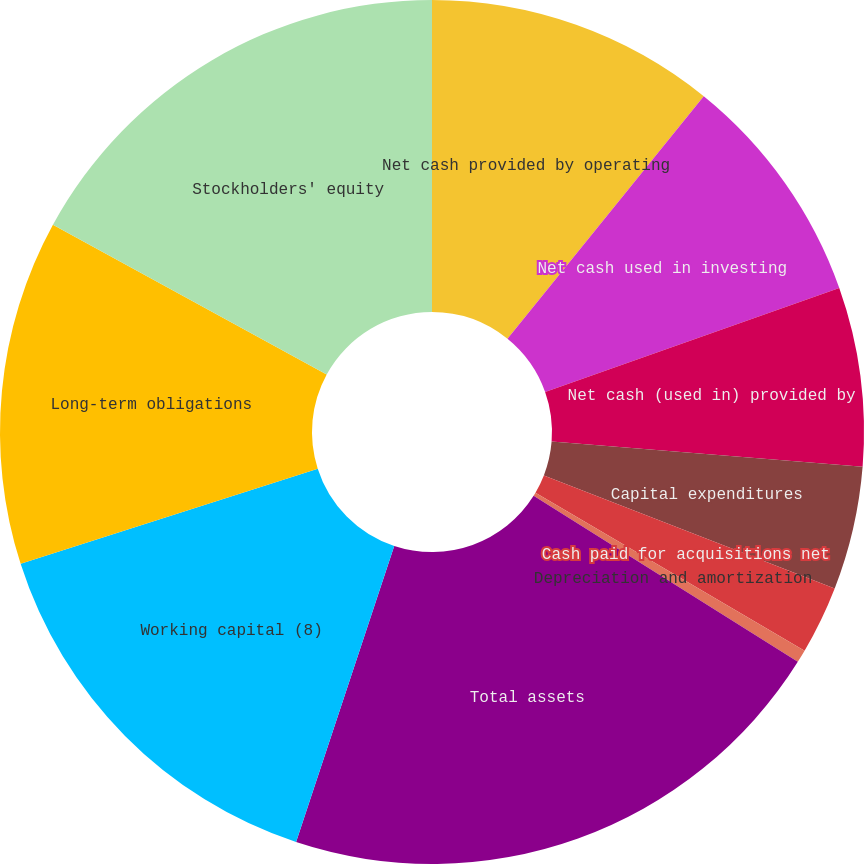<chart> <loc_0><loc_0><loc_500><loc_500><pie_chart><fcel>Net cash provided by operating<fcel>Net cash used in investing<fcel>Net cash (used in) provided by<fcel>Capital expenditures<fcel>Cash paid for acquisitions net<fcel>Depreciation and amortization<fcel>Total assets<fcel>Working capital (8)<fcel>Long-term obligations<fcel>Stockholders' equity<nl><fcel>10.83%<fcel>8.76%<fcel>6.69%<fcel>4.62%<fcel>2.55%<fcel>0.48%<fcel>21.17%<fcel>14.97%<fcel>12.9%<fcel>17.04%<nl></chart> 